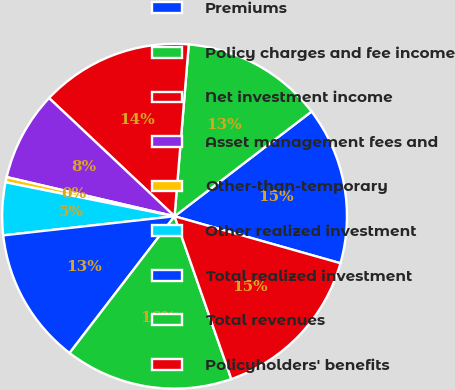Convert chart to OTSL. <chart><loc_0><loc_0><loc_500><loc_500><pie_chart><fcel>Premiums<fcel>Policy charges and fee income<fcel>Net investment income<fcel>Asset management fees and<fcel>Other-than-temporary<fcel>Other realized investment<fcel>Total realized investment<fcel>Total revenues<fcel>Policyholders' benefits<nl><fcel>14.78%<fcel>13.3%<fcel>14.29%<fcel>8.37%<fcel>0.49%<fcel>4.93%<fcel>12.81%<fcel>15.76%<fcel>15.27%<nl></chart> 